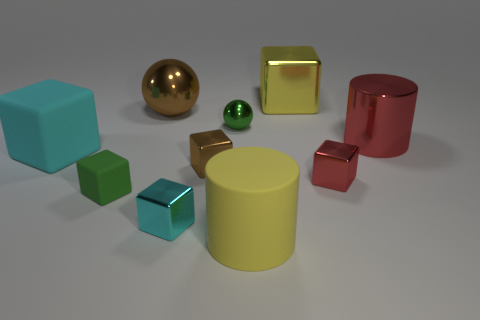There is a big object that is the same material as the yellow cylinder; what is its color?
Offer a terse response. Cyan. What number of metal things are either tiny cyan spheres or large blocks?
Give a very brief answer. 1. The red object that is the same size as the brown shiny ball is what shape?
Keep it short and to the point. Cylinder. How many things are shiny blocks behind the red cylinder or yellow things behind the large brown shiny sphere?
Provide a short and direct response. 1. What material is the cyan cube that is the same size as the brown shiny block?
Offer a terse response. Metal. How many other things are there of the same material as the tiny brown cube?
Your answer should be very brief. 6. Are there an equal number of cyan rubber cubes that are behind the large shiny cylinder and small green metal objects to the right of the green sphere?
Ensure brevity in your answer.  Yes. What number of brown objects are either small rubber cubes or blocks?
Make the answer very short. 1. There is a shiny cylinder; is it the same color as the big cube on the left side of the green ball?
Your response must be concise. No. How many other things are the same color as the tiny rubber thing?
Your answer should be very brief. 1. 